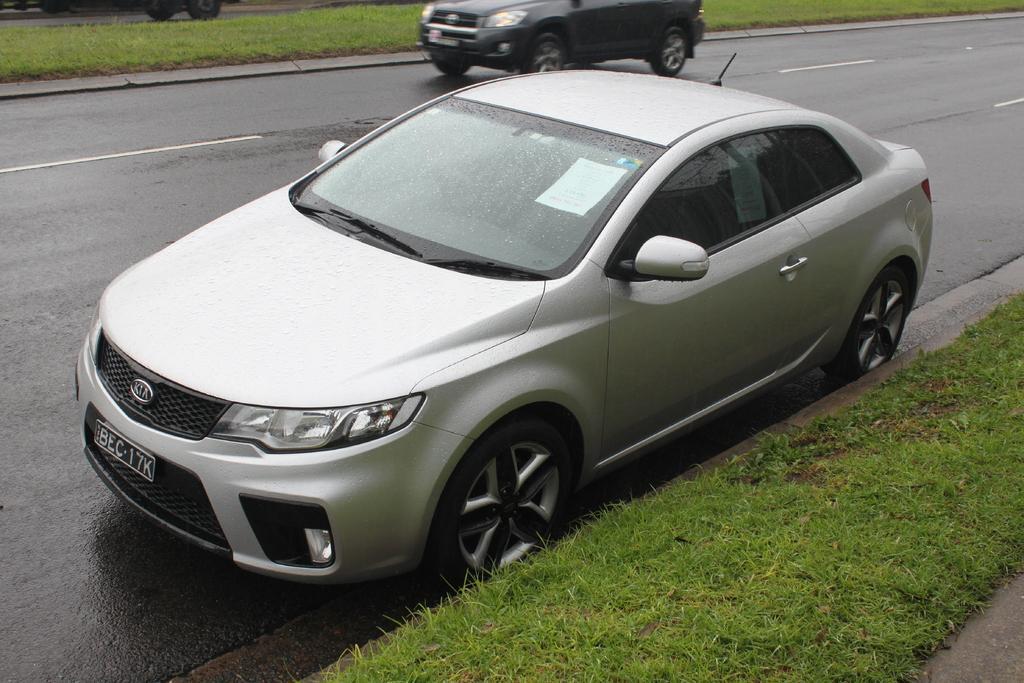How would you summarize this image in a sentence or two? In this image there is a road on which there are two cars. At the bottom there is grass. There are droplets of water on the car mirror. 